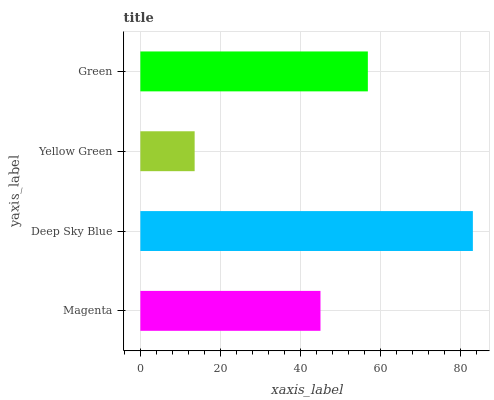Is Yellow Green the minimum?
Answer yes or no. Yes. Is Deep Sky Blue the maximum?
Answer yes or no. Yes. Is Deep Sky Blue the minimum?
Answer yes or no. No. Is Yellow Green the maximum?
Answer yes or no. No. Is Deep Sky Blue greater than Yellow Green?
Answer yes or no. Yes. Is Yellow Green less than Deep Sky Blue?
Answer yes or no. Yes. Is Yellow Green greater than Deep Sky Blue?
Answer yes or no. No. Is Deep Sky Blue less than Yellow Green?
Answer yes or no. No. Is Green the high median?
Answer yes or no. Yes. Is Magenta the low median?
Answer yes or no. Yes. Is Deep Sky Blue the high median?
Answer yes or no. No. Is Yellow Green the low median?
Answer yes or no. No. 